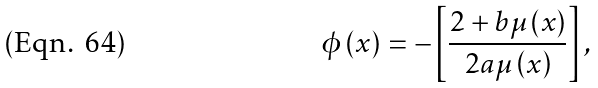<formula> <loc_0><loc_0><loc_500><loc_500>\phi \left ( x \right ) = - \left [ \frac { 2 + b \mu \left ( x \right ) } { 2 a \mu \left ( x \right ) } \right ] ,</formula> 